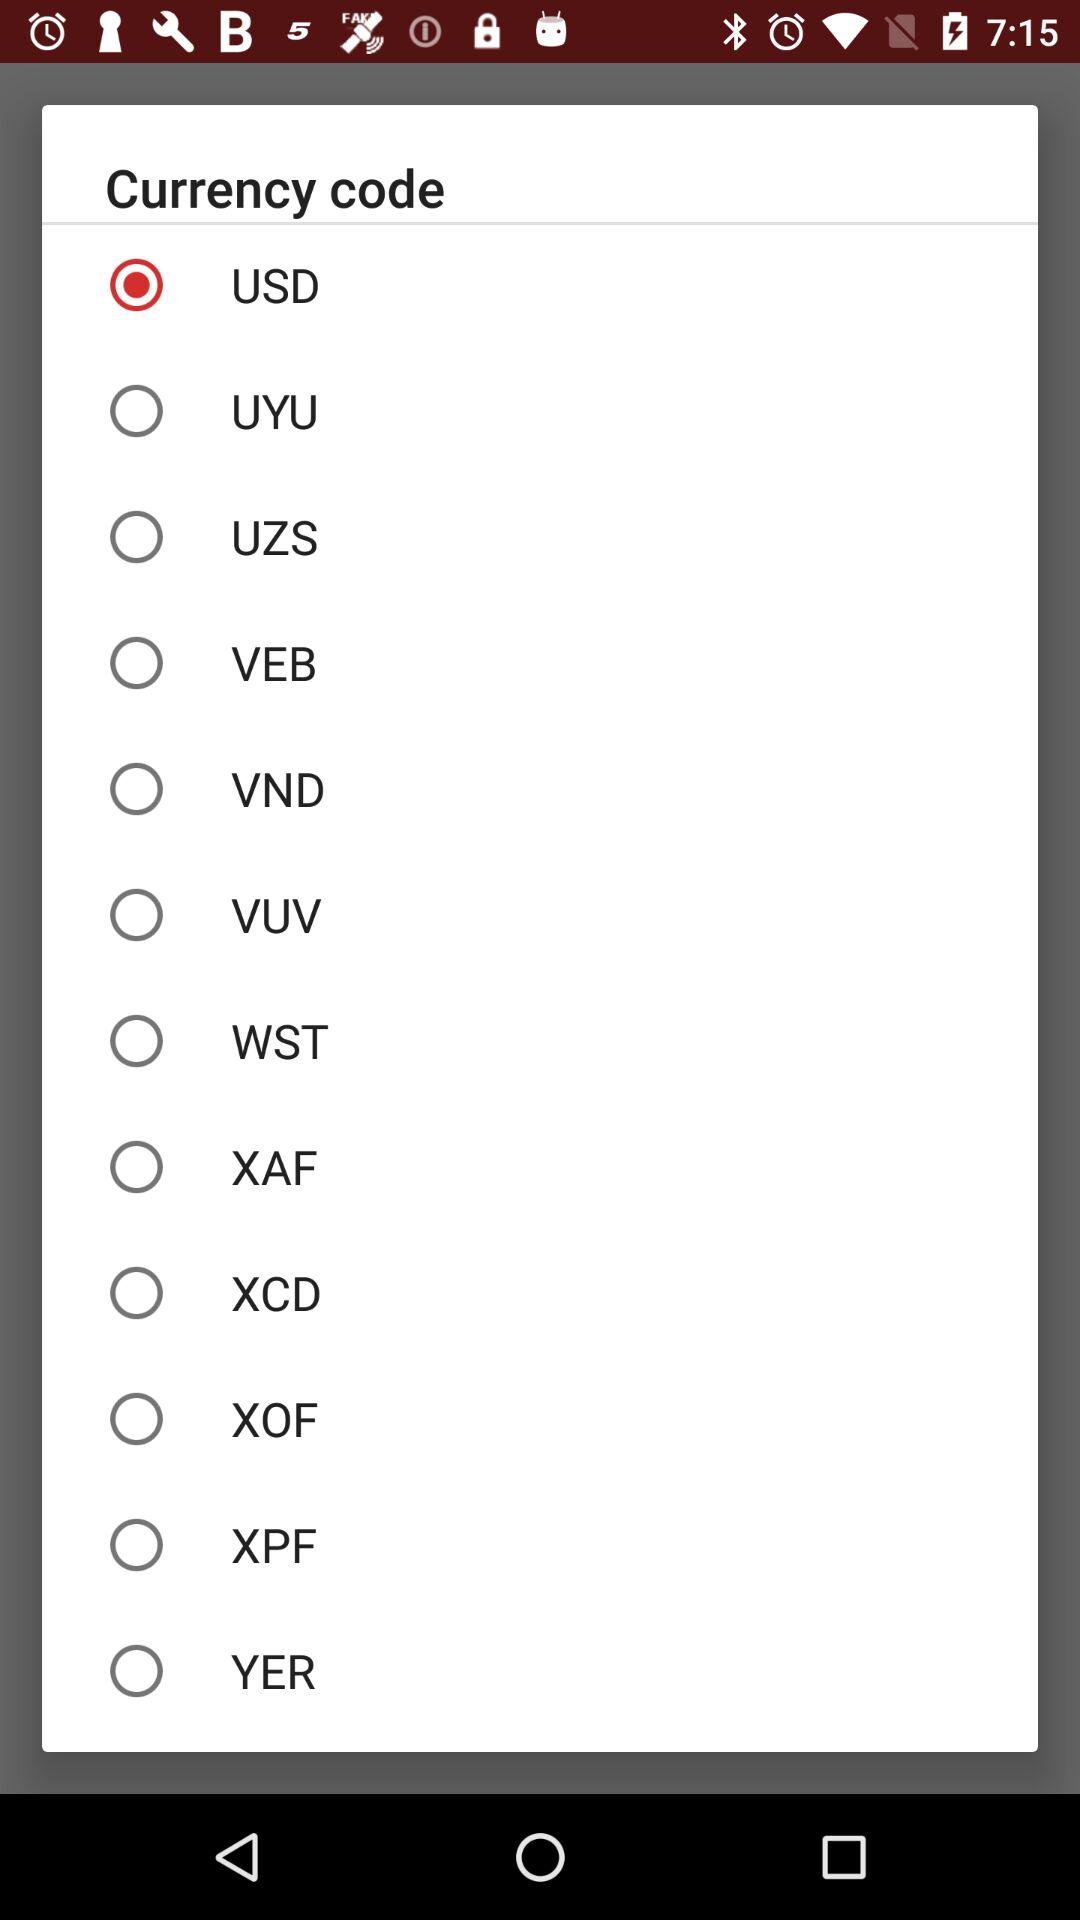What is the selected currency code? The selected currency code is USD. 